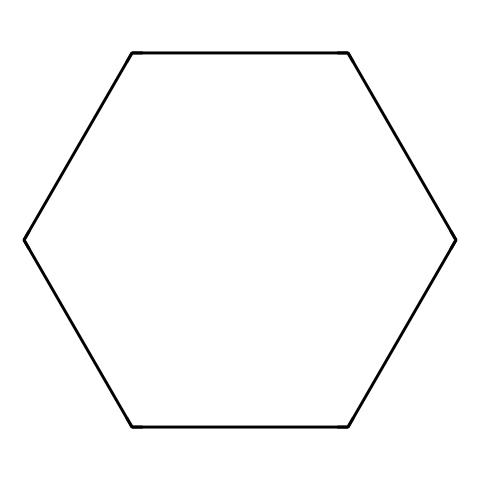What is the molecular formula of this compound? The SMILES representation shows six carbon atoms (C) connected in a cyclic structure with no double or triple bonds. Each carbon is also bonded to two hydrogen atoms (H), making the formula C6H12.
Answer: C6H12 How many hydrogen atoms are present in cyclohexane? Cyclohexane consists of six carbon atoms, and each carbon in this saturated compound is bonded to two hydrogen atoms, leading to a total of 12 hydrogen atoms.
Answer: 12 Is cyclohexane a saturated or unsaturated hydrocarbon? The chemical structure shows only single bonds with no double bonds among the carbon atoms, indicating it is saturated as it contains the maximum number of hydrogen atoms for its carbon structure.
Answer: saturated What type of compound is cyclohexane categorized as? As cyclohexane consists only of carbon and hydrogen atoms, and has a continuous chain of carbon atoms, it is classified as an aliphatic compound.
Answer: aliphatic What kind of bond connects the carbon atoms in cyclohexane? The SMILES notation indicates that all carbon atoms are connected by single bonds, these are sigma bonds which are characteristic of aliphatic compounds like cyclohexane.
Answer: single bonds How many rings are present in the structure of cyclohexane? The provided SMILES representation indicates a cyclical arrangement of the carbon atoms, thus forming a single ring structure in cyclohexane.
Answer: 1 What industrial applications is cyclohexane commonly used for? Cyclohexane is often used as a solvent in various industrial cleaning agents and can also be used as a precursor for the synthesis of nylon, confirming its utility in hardware cleaning processes.
Answer: cleaning agents 